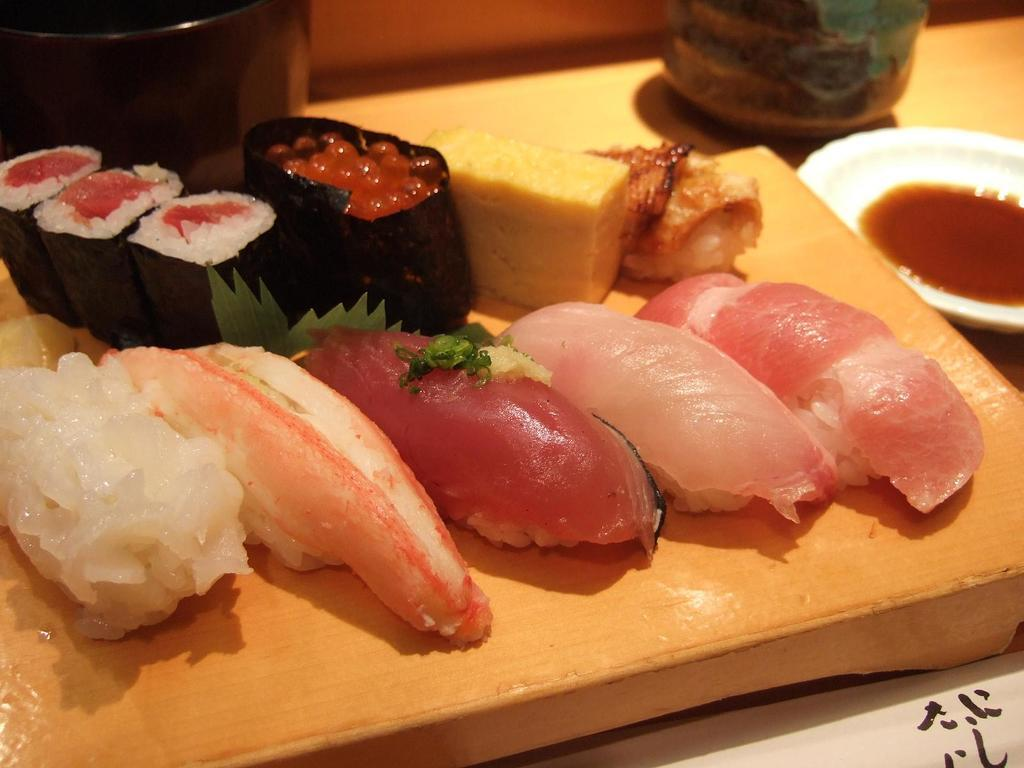What types of food items can be seen in the image? There are different food items in the image. What is used to hold the food items? There is a bowl in the image. What else is used to hold items in the image? There are cups in the image. On what surface are the food items, bowl, and cups placed? There is a table in the image. What type of insurance is being discussed in the image? There is no discussion of insurance in the image; it features food items, a bowl, cups, and a table. What is the back of the table like in the image? The image does not show the back of the table, as it only displays the surface where the food items, bowl, and cups are placed. 